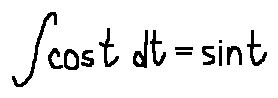Convert formula to latex. <formula><loc_0><loc_0><loc_500><loc_500>\int \cos t d t = \sin t</formula> 